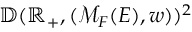Convert formula to latex. <formula><loc_0><loc_0><loc_500><loc_500>\mathbb { D } ( \mathbb { R } _ { + } , ( \mathcal { M } _ { F } ( E ) , w ) ) ^ { 2 }</formula> 